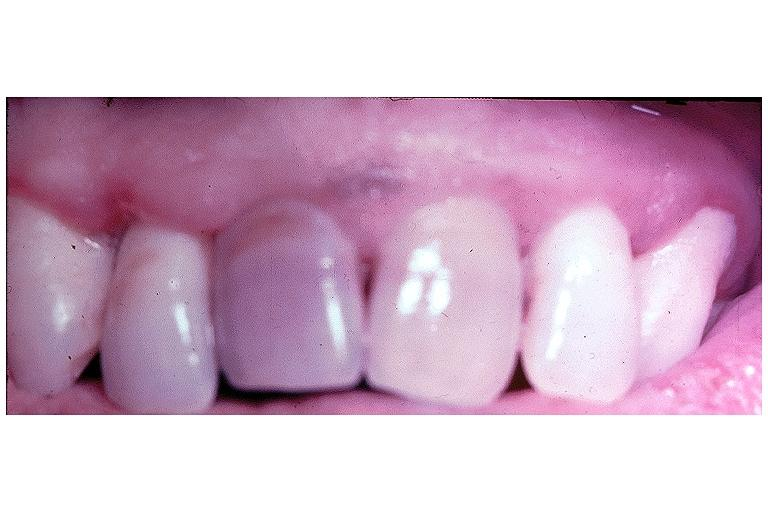s oral present?
Answer the question using a single word or phrase. Yes 